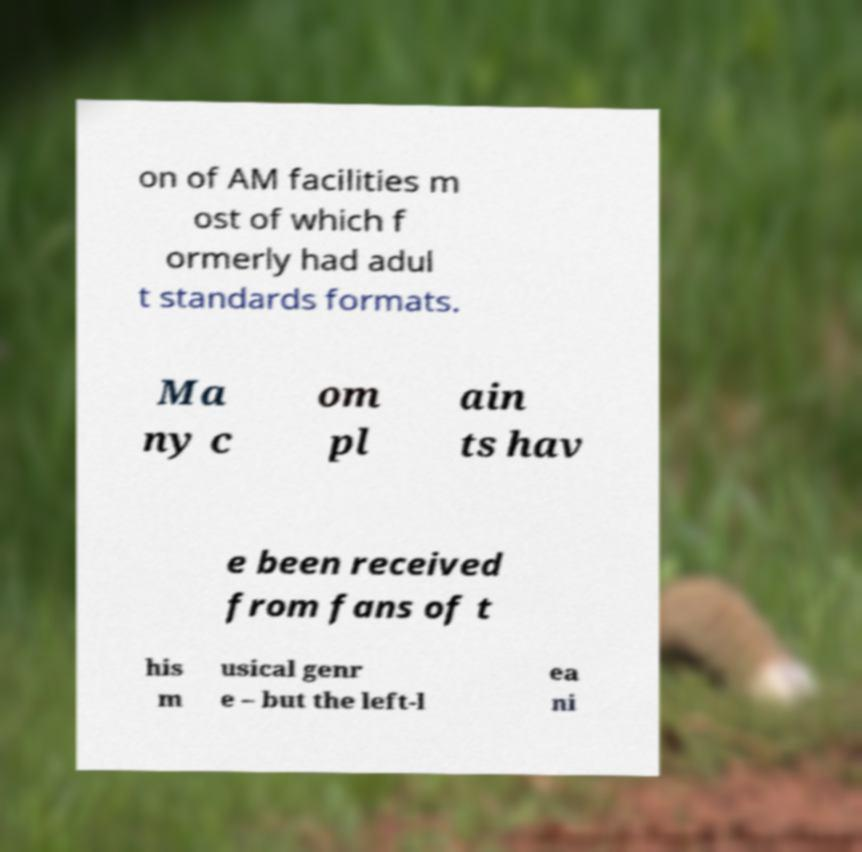There's text embedded in this image that I need extracted. Can you transcribe it verbatim? on of AM facilities m ost of which f ormerly had adul t standards formats. Ma ny c om pl ain ts hav e been received from fans of t his m usical genr e – but the left-l ea ni 